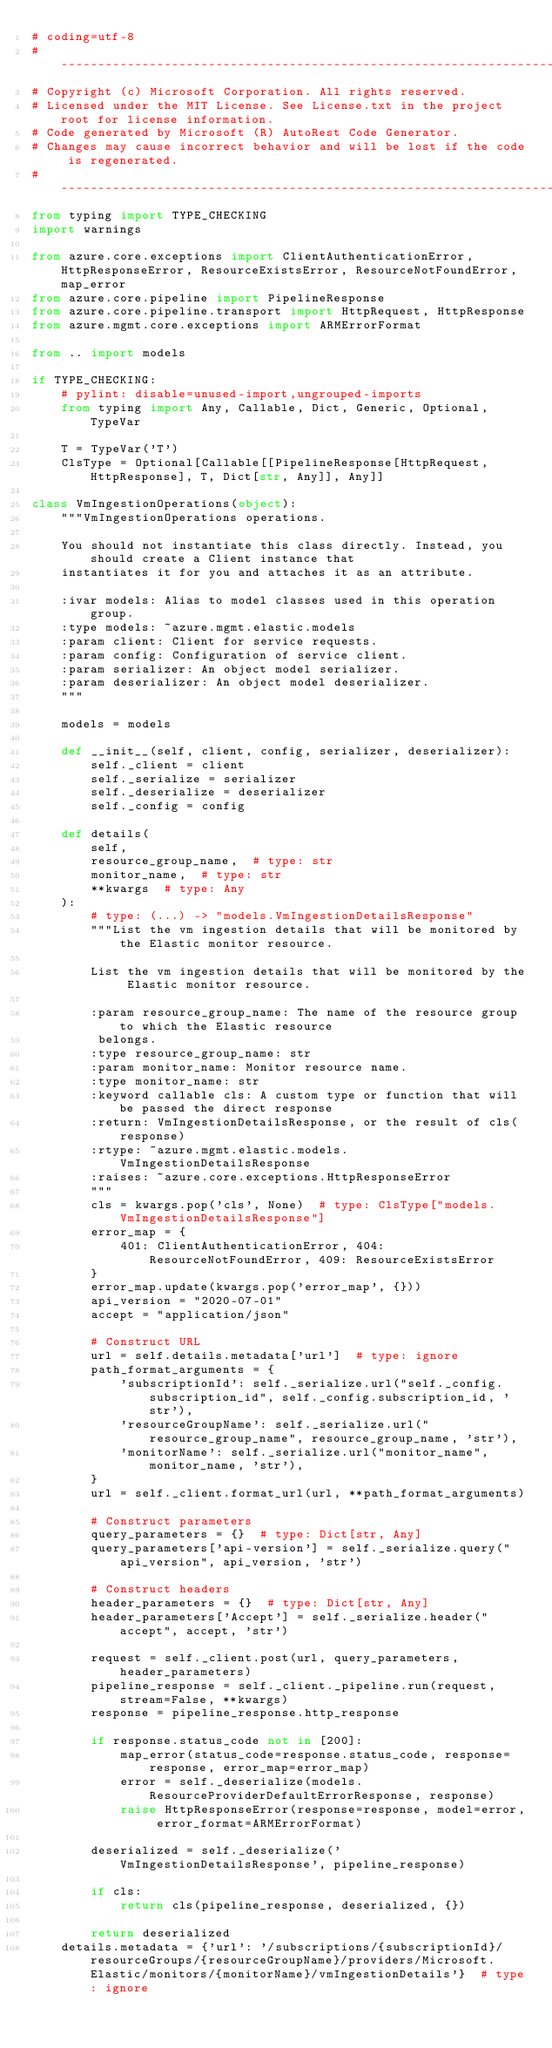<code> <loc_0><loc_0><loc_500><loc_500><_Python_># coding=utf-8
# --------------------------------------------------------------------------
# Copyright (c) Microsoft Corporation. All rights reserved.
# Licensed under the MIT License. See License.txt in the project root for license information.
# Code generated by Microsoft (R) AutoRest Code Generator.
# Changes may cause incorrect behavior and will be lost if the code is regenerated.
# --------------------------------------------------------------------------
from typing import TYPE_CHECKING
import warnings

from azure.core.exceptions import ClientAuthenticationError, HttpResponseError, ResourceExistsError, ResourceNotFoundError, map_error
from azure.core.pipeline import PipelineResponse
from azure.core.pipeline.transport import HttpRequest, HttpResponse
from azure.mgmt.core.exceptions import ARMErrorFormat

from .. import models

if TYPE_CHECKING:
    # pylint: disable=unused-import,ungrouped-imports
    from typing import Any, Callable, Dict, Generic, Optional, TypeVar

    T = TypeVar('T')
    ClsType = Optional[Callable[[PipelineResponse[HttpRequest, HttpResponse], T, Dict[str, Any]], Any]]

class VmIngestionOperations(object):
    """VmIngestionOperations operations.

    You should not instantiate this class directly. Instead, you should create a Client instance that
    instantiates it for you and attaches it as an attribute.

    :ivar models: Alias to model classes used in this operation group.
    :type models: ~azure.mgmt.elastic.models
    :param client: Client for service requests.
    :param config: Configuration of service client.
    :param serializer: An object model serializer.
    :param deserializer: An object model deserializer.
    """

    models = models

    def __init__(self, client, config, serializer, deserializer):
        self._client = client
        self._serialize = serializer
        self._deserialize = deserializer
        self._config = config

    def details(
        self,
        resource_group_name,  # type: str
        monitor_name,  # type: str
        **kwargs  # type: Any
    ):
        # type: (...) -> "models.VmIngestionDetailsResponse"
        """List the vm ingestion details that will be monitored by the Elastic monitor resource.

        List the vm ingestion details that will be monitored by the Elastic monitor resource.

        :param resource_group_name: The name of the resource group to which the Elastic resource
         belongs.
        :type resource_group_name: str
        :param monitor_name: Monitor resource name.
        :type monitor_name: str
        :keyword callable cls: A custom type or function that will be passed the direct response
        :return: VmIngestionDetailsResponse, or the result of cls(response)
        :rtype: ~azure.mgmt.elastic.models.VmIngestionDetailsResponse
        :raises: ~azure.core.exceptions.HttpResponseError
        """
        cls = kwargs.pop('cls', None)  # type: ClsType["models.VmIngestionDetailsResponse"]
        error_map = {
            401: ClientAuthenticationError, 404: ResourceNotFoundError, 409: ResourceExistsError
        }
        error_map.update(kwargs.pop('error_map', {}))
        api_version = "2020-07-01"
        accept = "application/json"

        # Construct URL
        url = self.details.metadata['url']  # type: ignore
        path_format_arguments = {
            'subscriptionId': self._serialize.url("self._config.subscription_id", self._config.subscription_id, 'str'),
            'resourceGroupName': self._serialize.url("resource_group_name", resource_group_name, 'str'),
            'monitorName': self._serialize.url("monitor_name", monitor_name, 'str'),
        }
        url = self._client.format_url(url, **path_format_arguments)

        # Construct parameters
        query_parameters = {}  # type: Dict[str, Any]
        query_parameters['api-version'] = self._serialize.query("api_version", api_version, 'str')

        # Construct headers
        header_parameters = {}  # type: Dict[str, Any]
        header_parameters['Accept'] = self._serialize.header("accept", accept, 'str')

        request = self._client.post(url, query_parameters, header_parameters)
        pipeline_response = self._client._pipeline.run(request, stream=False, **kwargs)
        response = pipeline_response.http_response

        if response.status_code not in [200]:
            map_error(status_code=response.status_code, response=response, error_map=error_map)
            error = self._deserialize(models.ResourceProviderDefaultErrorResponse, response)
            raise HttpResponseError(response=response, model=error, error_format=ARMErrorFormat)

        deserialized = self._deserialize('VmIngestionDetailsResponse', pipeline_response)

        if cls:
            return cls(pipeline_response, deserialized, {})

        return deserialized
    details.metadata = {'url': '/subscriptions/{subscriptionId}/resourceGroups/{resourceGroupName}/providers/Microsoft.Elastic/monitors/{monitorName}/vmIngestionDetails'}  # type: ignore
</code> 